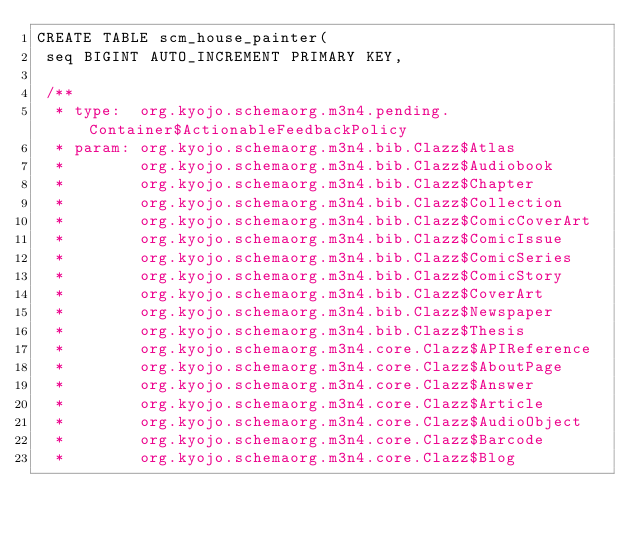<code> <loc_0><loc_0><loc_500><loc_500><_SQL_>CREATE TABLE scm_house_painter(
 seq BIGINT AUTO_INCREMENT PRIMARY KEY,

 /**
  * type:  org.kyojo.schemaorg.m3n4.pending.Container$ActionableFeedbackPolicy
  * param: org.kyojo.schemaorg.m3n4.bib.Clazz$Atlas
  *        org.kyojo.schemaorg.m3n4.bib.Clazz$Audiobook
  *        org.kyojo.schemaorg.m3n4.bib.Clazz$Chapter
  *        org.kyojo.schemaorg.m3n4.bib.Clazz$Collection
  *        org.kyojo.schemaorg.m3n4.bib.Clazz$ComicCoverArt
  *        org.kyojo.schemaorg.m3n4.bib.Clazz$ComicIssue
  *        org.kyojo.schemaorg.m3n4.bib.Clazz$ComicSeries
  *        org.kyojo.schemaorg.m3n4.bib.Clazz$ComicStory
  *        org.kyojo.schemaorg.m3n4.bib.Clazz$CoverArt
  *        org.kyojo.schemaorg.m3n4.bib.Clazz$Newspaper
  *        org.kyojo.schemaorg.m3n4.bib.Clazz$Thesis
  *        org.kyojo.schemaorg.m3n4.core.Clazz$APIReference
  *        org.kyojo.schemaorg.m3n4.core.Clazz$AboutPage
  *        org.kyojo.schemaorg.m3n4.core.Clazz$Answer
  *        org.kyojo.schemaorg.m3n4.core.Clazz$Article
  *        org.kyojo.schemaorg.m3n4.core.Clazz$AudioObject
  *        org.kyojo.schemaorg.m3n4.core.Clazz$Barcode
  *        org.kyojo.schemaorg.m3n4.core.Clazz$Blog</code> 